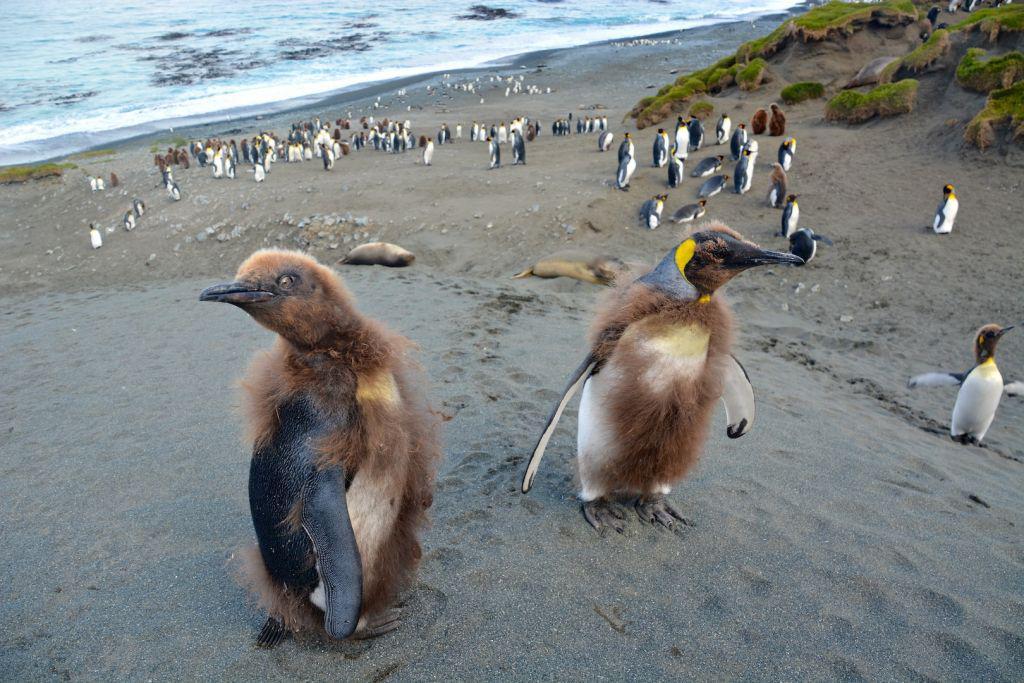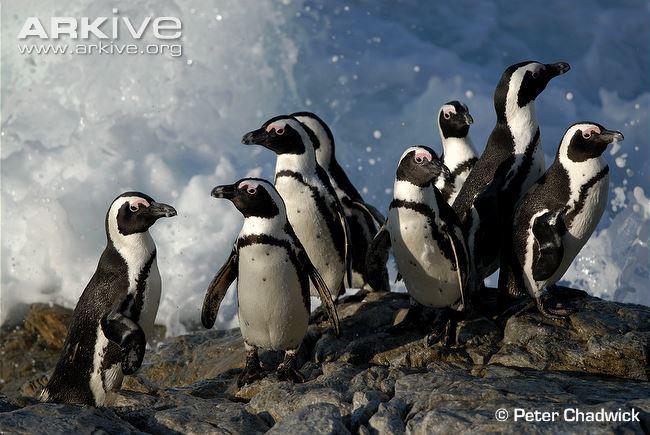The first image is the image on the left, the second image is the image on the right. Assess this claim about the two images: "An image shows two foreground penguins with furry patches.". Correct or not? Answer yes or no. Yes. The first image is the image on the left, the second image is the image on the right. For the images shown, is this caption "There is one image with two penguins standing on ice." true? Answer yes or no. No. 